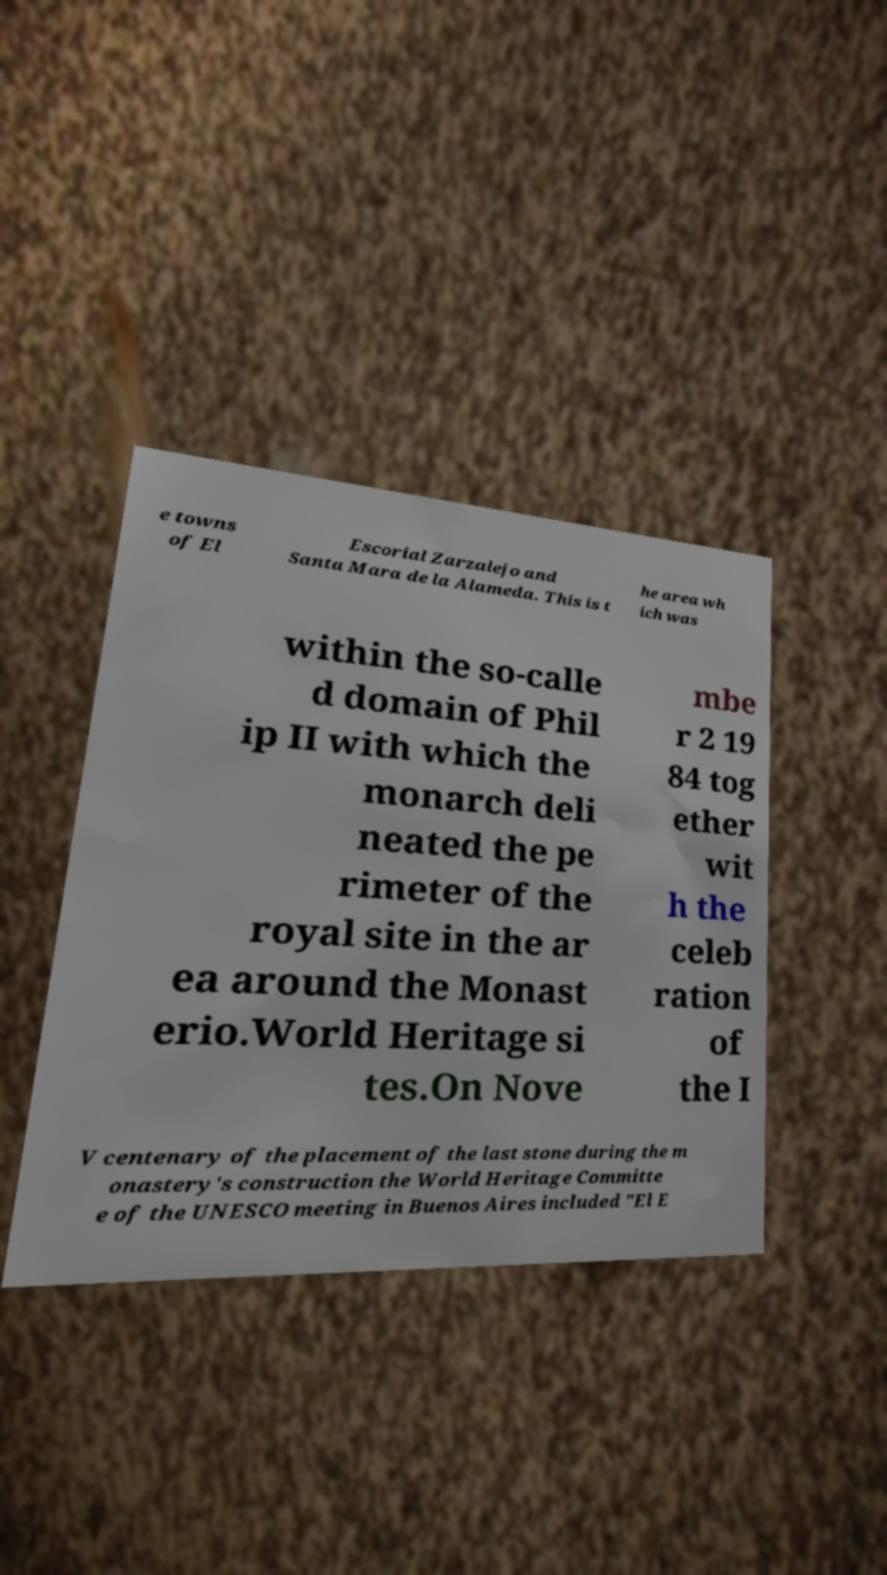Please identify and transcribe the text found in this image. e towns of El Escorial Zarzalejo and Santa Mara de la Alameda. This is t he area wh ich was within the so-calle d domain of Phil ip II with which the monarch deli neated the pe rimeter of the royal site in the ar ea around the Monast erio.World Heritage si tes.On Nove mbe r 2 19 84 tog ether wit h the celeb ration of the I V centenary of the placement of the last stone during the m onastery's construction the World Heritage Committe e of the UNESCO meeting in Buenos Aires included "El E 